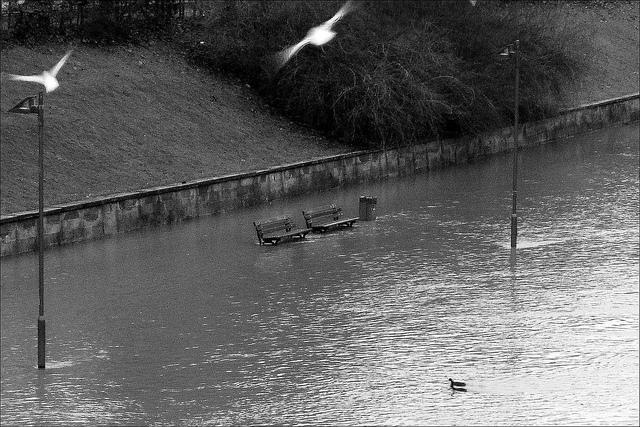How many park benches have been flooded?
Write a very short answer. 2. What is in the water?
Write a very short answer. Benches. Is there a duck swimming in the water?
Keep it brief. Yes. Do birds like sailing on a tree stem in the water?
Concise answer only. Yes. Is this area flooded?
Keep it brief. Yes. 